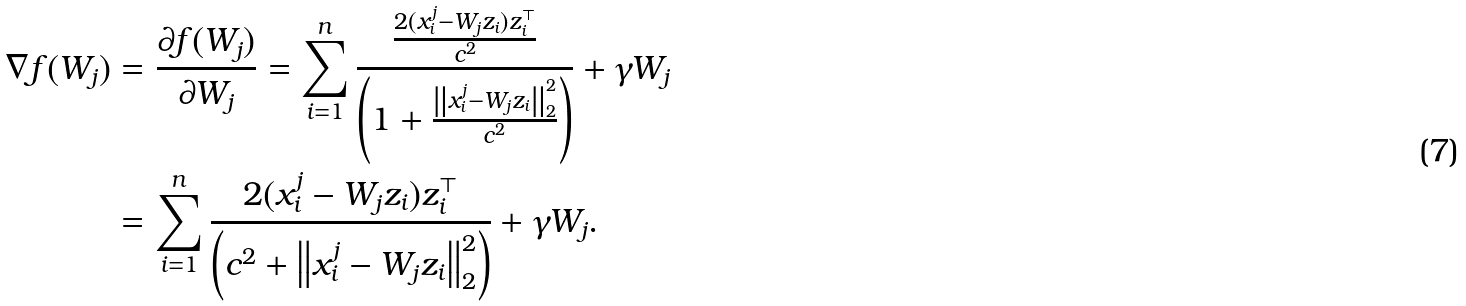<formula> <loc_0><loc_0><loc_500><loc_500>\nabla f ( W _ { j } ) & = \frac { \partial f ( W _ { j } ) } { \partial W _ { j } } = \sum _ { i = 1 } ^ { n } \frac { \frac { 2 ( x _ { i } ^ { j } - W _ { j } z _ { i } ) z _ { i } ^ { \top } } { c ^ { 2 } } } { \left ( 1 + \frac { \left \| x _ { i } ^ { j } - W _ { j } z _ { i } \right \| _ { 2 } ^ { 2 } } { c ^ { 2 } } \right ) } + \gamma W _ { j } \\ & = \sum _ { i = 1 } ^ { n } \frac { 2 ( x _ { i } ^ { j } - W _ { j } z _ { i } ) z _ { i } ^ { \top } } { \left ( c ^ { 2 } + \left \| x _ { i } ^ { j } - W _ { j } z _ { i } \right \| _ { 2 } ^ { 2 } \right ) } + \gamma W _ { j } .</formula> 